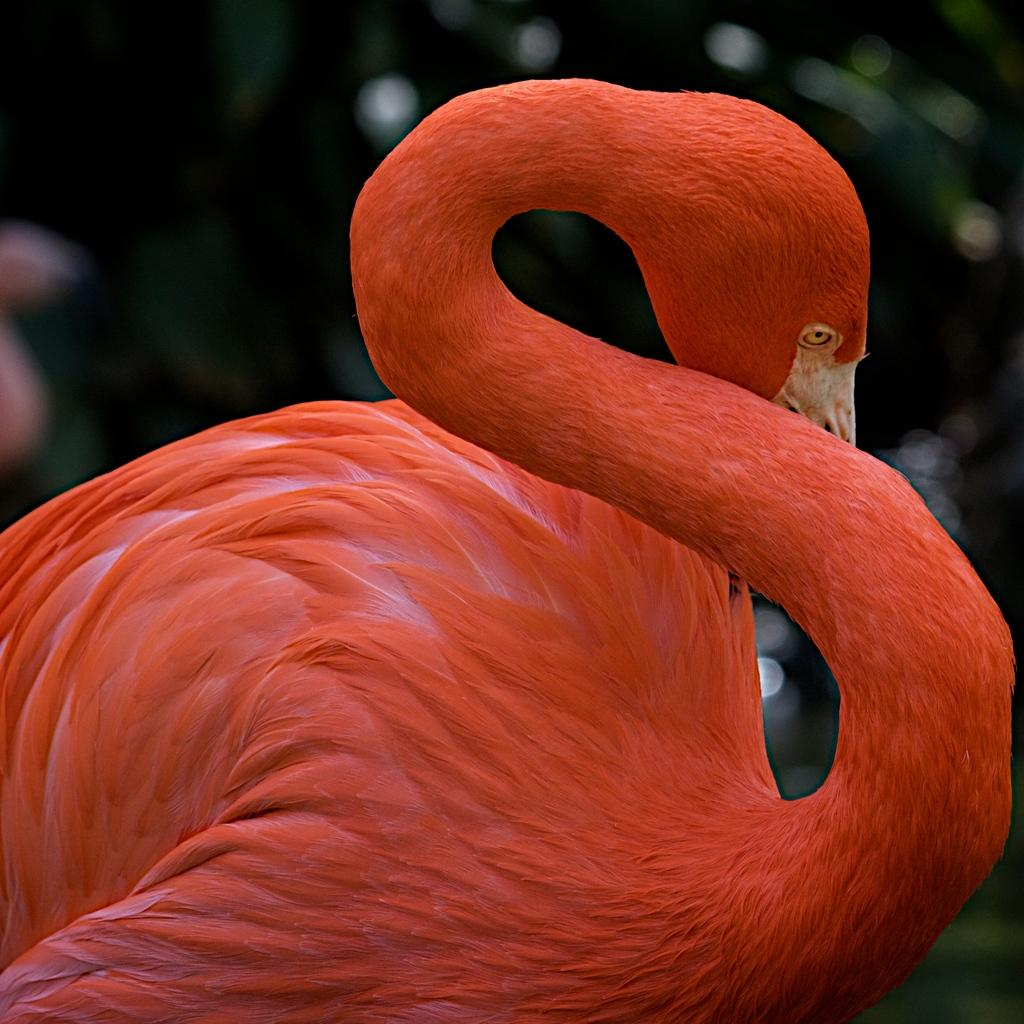What is the main subject of the picture? The main subject of the picture is a red color swan. Can you describe the background of the image? The background of the image is blurred. What type of car can be seen driving in the background of the image? There is no car visible in the image; the background is blurred and only the red color swan is the main subject. What time of day is it in the image, considering it's an afternoon scene? The time of day cannot be determined from the image, as there are no specific details or indicators of the time. 